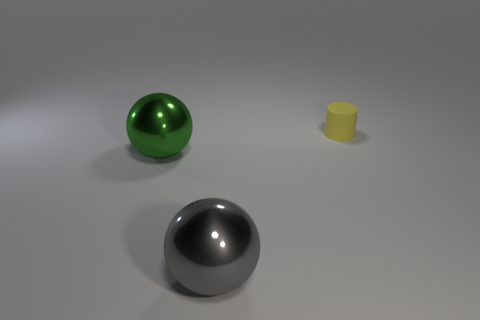Subtract all gray spheres. Subtract all purple cylinders. How many spheres are left? 1 Add 2 tiny rubber cylinders. How many objects exist? 5 Subtract all balls. How many objects are left? 1 Subtract all big brown metal cylinders. Subtract all shiny balls. How many objects are left? 1 Add 1 matte cylinders. How many matte cylinders are left? 2 Add 3 large purple shiny cylinders. How many large purple shiny cylinders exist? 3 Subtract 0 cyan cubes. How many objects are left? 3 